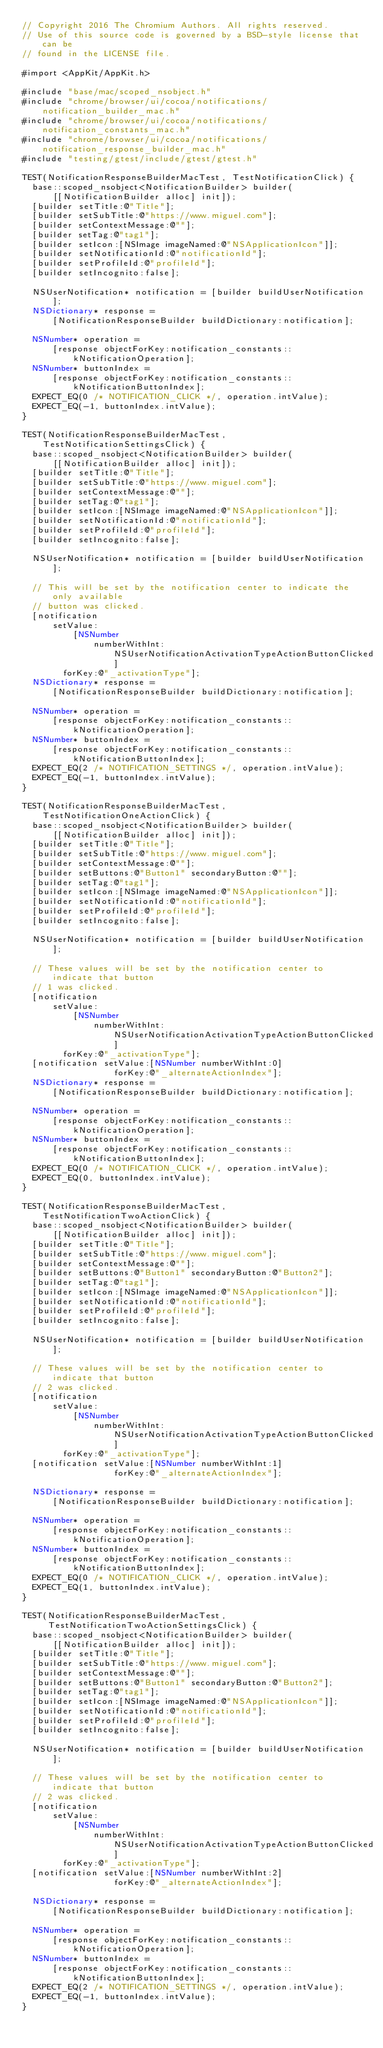Convert code to text. <code><loc_0><loc_0><loc_500><loc_500><_ObjectiveC_>// Copyright 2016 The Chromium Authors. All rights reserved.
// Use of this source code is governed by a BSD-style license that can be
// found in the LICENSE file.

#import <AppKit/AppKit.h>

#include "base/mac/scoped_nsobject.h"
#include "chrome/browser/ui/cocoa/notifications/notification_builder_mac.h"
#include "chrome/browser/ui/cocoa/notifications/notification_constants_mac.h"
#include "chrome/browser/ui/cocoa/notifications/notification_response_builder_mac.h"
#include "testing/gtest/include/gtest/gtest.h"

TEST(NotificationResponseBuilderMacTest, TestNotificationClick) {
  base::scoped_nsobject<NotificationBuilder> builder(
      [[NotificationBuilder alloc] init]);
  [builder setTitle:@"Title"];
  [builder setSubTitle:@"https://www.miguel.com"];
  [builder setContextMessage:@""];
  [builder setTag:@"tag1"];
  [builder setIcon:[NSImage imageNamed:@"NSApplicationIcon"]];
  [builder setNotificationId:@"notificationId"];
  [builder setProfileId:@"profileId"];
  [builder setIncognito:false];

  NSUserNotification* notification = [builder buildUserNotification];
  NSDictionary* response =
      [NotificationResponseBuilder buildDictionary:notification];

  NSNumber* operation =
      [response objectForKey:notification_constants::kNotificationOperation];
  NSNumber* buttonIndex =
      [response objectForKey:notification_constants::kNotificationButtonIndex];
  EXPECT_EQ(0 /* NOTIFICATION_CLICK */, operation.intValue);
  EXPECT_EQ(-1, buttonIndex.intValue);
}

TEST(NotificationResponseBuilderMacTest, TestNotificationSettingsClick) {
  base::scoped_nsobject<NotificationBuilder> builder(
      [[NotificationBuilder alloc] init]);
  [builder setTitle:@"Title"];
  [builder setSubTitle:@"https://www.miguel.com"];
  [builder setContextMessage:@""];
  [builder setTag:@"tag1"];
  [builder setIcon:[NSImage imageNamed:@"NSApplicationIcon"]];
  [builder setNotificationId:@"notificationId"];
  [builder setProfileId:@"profileId"];
  [builder setIncognito:false];

  NSUserNotification* notification = [builder buildUserNotification];

  // This will be set by the notification center to indicate the only available
  // button was clicked.
  [notification
      setValue:
          [NSNumber
              numberWithInt:NSUserNotificationActivationTypeActionButtonClicked]
        forKey:@"_activationType"];
  NSDictionary* response =
      [NotificationResponseBuilder buildDictionary:notification];

  NSNumber* operation =
      [response objectForKey:notification_constants::kNotificationOperation];
  NSNumber* buttonIndex =
      [response objectForKey:notification_constants::kNotificationButtonIndex];
  EXPECT_EQ(2 /* NOTIFICATION_SETTINGS */, operation.intValue);
  EXPECT_EQ(-1, buttonIndex.intValue);
}

TEST(NotificationResponseBuilderMacTest, TestNotificationOneActionClick) {
  base::scoped_nsobject<NotificationBuilder> builder(
      [[NotificationBuilder alloc] init]);
  [builder setTitle:@"Title"];
  [builder setSubTitle:@"https://www.miguel.com"];
  [builder setContextMessage:@""];
  [builder setButtons:@"Button1" secondaryButton:@""];
  [builder setTag:@"tag1"];
  [builder setIcon:[NSImage imageNamed:@"NSApplicationIcon"]];
  [builder setNotificationId:@"notificationId"];
  [builder setProfileId:@"profileId"];
  [builder setIncognito:false];

  NSUserNotification* notification = [builder buildUserNotification];

  // These values will be set by the notification center to indicate that button
  // 1 was clicked.
  [notification
      setValue:
          [NSNumber
              numberWithInt:NSUserNotificationActivationTypeActionButtonClicked]
        forKey:@"_activationType"];
  [notification setValue:[NSNumber numberWithInt:0]
                  forKey:@"_alternateActionIndex"];
  NSDictionary* response =
      [NotificationResponseBuilder buildDictionary:notification];

  NSNumber* operation =
      [response objectForKey:notification_constants::kNotificationOperation];
  NSNumber* buttonIndex =
      [response objectForKey:notification_constants::kNotificationButtonIndex];
  EXPECT_EQ(0 /* NOTIFICATION_CLICK */, operation.intValue);
  EXPECT_EQ(0, buttonIndex.intValue);
}

TEST(NotificationResponseBuilderMacTest, TestNotificationTwoActionClick) {
  base::scoped_nsobject<NotificationBuilder> builder(
      [[NotificationBuilder alloc] init]);
  [builder setTitle:@"Title"];
  [builder setSubTitle:@"https://www.miguel.com"];
  [builder setContextMessage:@""];
  [builder setButtons:@"Button1" secondaryButton:@"Button2"];
  [builder setTag:@"tag1"];
  [builder setIcon:[NSImage imageNamed:@"NSApplicationIcon"]];
  [builder setNotificationId:@"notificationId"];
  [builder setProfileId:@"profileId"];
  [builder setIncognito:false];

  NSUserNotification* notification = [builder buildUserNotification];

  // These values will be set by the notification center to indicate that button
  // 2 was clicked.
  [notification
      setValue:
          [NSNumber
              numberWithInt:NSUserNotificationActivationTypeActionButtonClicked]
        forKey:@"_activationType"];
  [notification setValue:[NSNumber numberWithInt:1]
                  forKey:@"_alternateActionIndex"];

  NSDictionary* response =
      [NotificationResponseBuilder buildDictionary:notification];

  NSNumber* operation =
      [response objectForKey:notification_constants::kNotificationOperation];
  NSNumber* buttonIndex =
      [response objectForKey:notification_constants::kNotificationButtonIndex];
  EXPECT_EQ(0 /* NOTIFICATION_CLICK */, operation.intValue);
  EXPECT_EQ(1, buttonIndex.intValue);
}

TEST(NotificationResponseBuilderMacTest,
     TestNotificationTwoActionSettingsClick) {
  base::scoped_nsobject<NotificationBuilder> builder(
      [[NotificationBuilder alloc] init]);
  [builder setTitle:@"Title"];
  [builder setSubTitle:@"https://www.miguel.com"];
  [builder setContextMessage:@""];
  [builder setButtons:@"Button1" secondaryButton:@"Button2"];
  [builder setTag:@"tag1"];
  [builder setIcon:[NSImage imageNamed:@"NSApplicationIcon"]];
  [builder setNotificationId:@"notificationId"];
  [builder setProfileId:@"profileId"];
  [builder setIncognito:false];

  NSUserNotification* notification = [builder buildUserNotification];

  // These values will be set by the notification center to indicate that button
  // 2 was clicked.
  [notification
      setValue:
          [NSNumber
              numberWithInt:NSUserNotificationActivationTypeActionButtonClicked]
        forKey:@"_activationType"];
  [notification setValue:[NSNumber numberWithInt:2]
                  forKey:@"_alternateActionIndex"];

  NSDictionary* response =
      [NotificationResponseBuilder buildDictionary:notification];

  NSNumber* operation =
      [response objectForKey:notification_constants::kNotificationOperation];
  NSNumber* buttonIndex =
      [response objectForKey:notification_constants::kNotificationButtonIndex];
  EXPECT_EQ(2 /* NOTIFICATION_SETTINGS */, operation.intValue);
  EXPECT_EQ(-1, buttonIndex.intValue);
}
</code> 